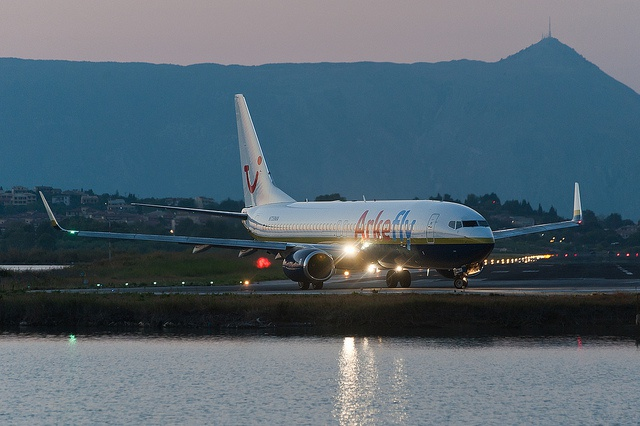Describe the objects in this image and their specific colors. I can see a airplane in darkgray, black, gray, and blue tones in this image. 